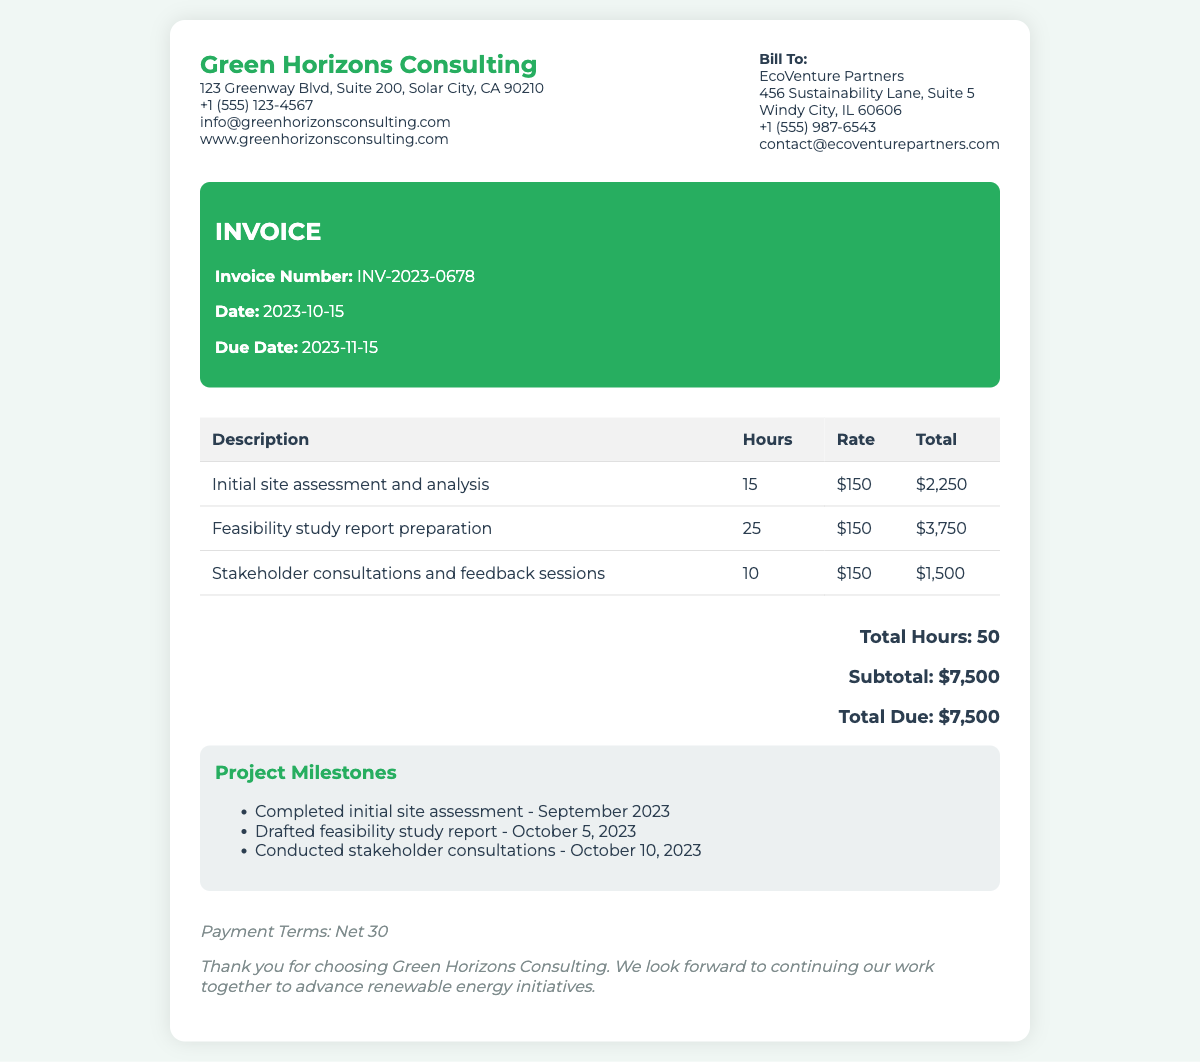What is the invoice number? The invoice number is specifically stated in the document as a unique identifier for the transaction.
Answer: INV-2023-0678 What is the total due? The total due is the final amount payable as mentioned in the invoice section.
Answer: $7,500 How many hours were billed for stakeholder consultations? The document lists the hours worked for each service provided, including stakeholder consultations.
Answer: 10 What is the date of the invoice? The date of the invoice indicates when the services were billed, which is included in the document.
Answer: 2023-10-15 What was the rate charged per hour? The hourly rate for consulting services is specified in the invoice details for all tasks.
Answer: $150 How many project milestones are listed? The milestones section summarizes the completed project tasks, which offers a count of milestones achieved.
Answer: 3 What was completed in September 2023? The milestones mention specific tasks completed by their dates, detailing what was done in September.
Answer: Initial site assessment When is the payment due? The document specifies the due date for payment, indicating when the payment is expected.
Answer: 2023-11-15 What company issued the invoice? The logo and company details at the top of the document identify the issuer of the invoice.
Answer: Green Horizons Consulting 